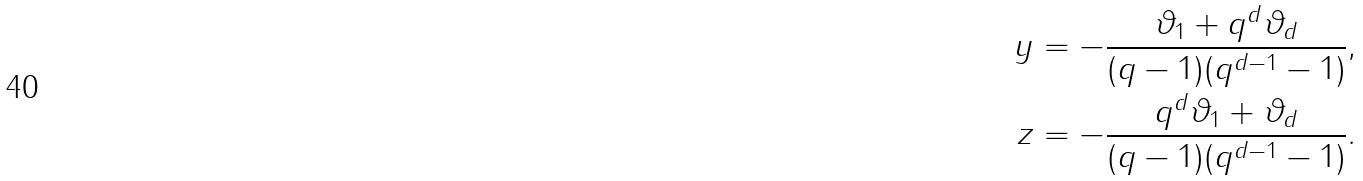<formula> <loc_0><loc_0><loc_500><loc_500>y & = - \frac { \vartheta _ { 1 } + q ^ { d } \vartheta _ { d } } { ( q - 1 ) ( q ^ { d - 1 } - 1 ) } , \\ z & = - \frac { q ^ { d } \vartheta _ { 1 } + \vartheta _ { d } } { ( q - 1 ) ( q ^ { d - 1 } - 1 ) } .</formula> 